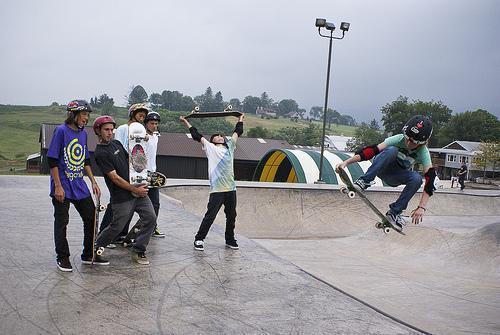How many people are wearing a yellow shirt?
Give a very brief answer. 0. How many umbrellas do you see?
Give a very brief answer. 0. How many people can you see?
Give a very brief answer. 4. How many cows are not black and white?
Give a very brief answer. 0. 